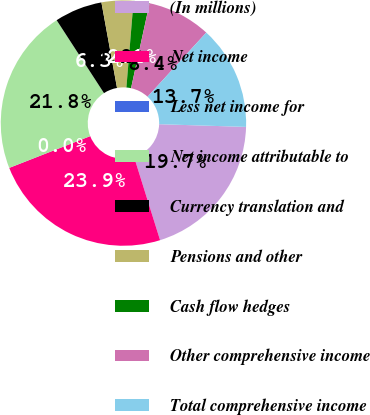<chart> <loc_0><loc_0><loc_500><loc_500><pie_chart><fcel>(In millions)<fcel>Net income<fcel>Less net income for<fcel>Net income attributable to<fcel>Currency translation and<fcel>Pensions and other<fcel>Cash flow hedges<fcel>Other comprehensive income<fcel>Total comprehensive income<nl><fcel>19.68%<fcel>23.87%<fcel>0.01%<fcel>21.78%<fcel>6.29%<fcel>4.19%<fcel>2.1%<fcel>8.38%<fcel>13.7%<nl></chart> 